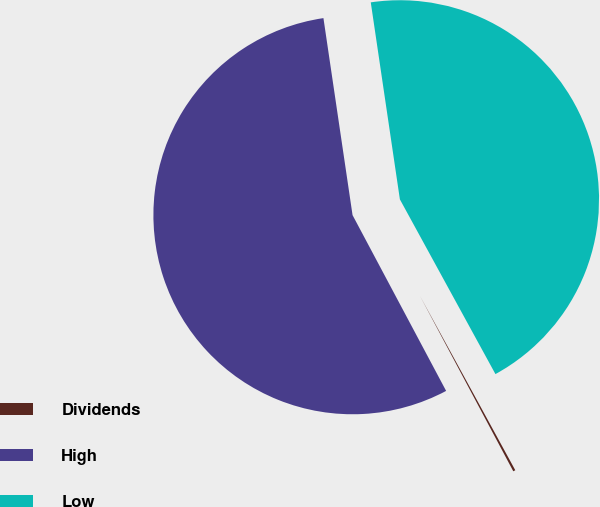<chart> <loc_0><loc_0><loc_500><loc_500><pie_chart><fcel>Dividends<fcel>High<fcel>Low<nl><fcel>0.18%<fcel>55.45%<fcel>44.37%<nl></chart> 